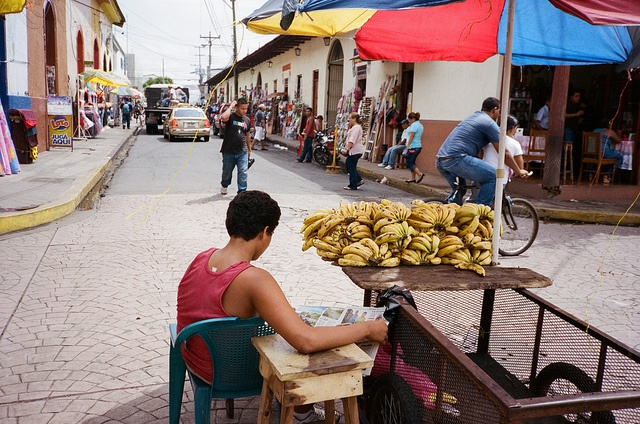Describe the objects in this image and their specific colors. I can see umbrella in olive, salmon, lightblue, gray, and khaki tones, people in olive, maroon, black, and salmon tones, chair in olive, black, maroon, darkblue, and teal tones, banana in olive, maroon, black, and tan tones, and people in olive, navy, black, darkblue, and gray tones in this image. 